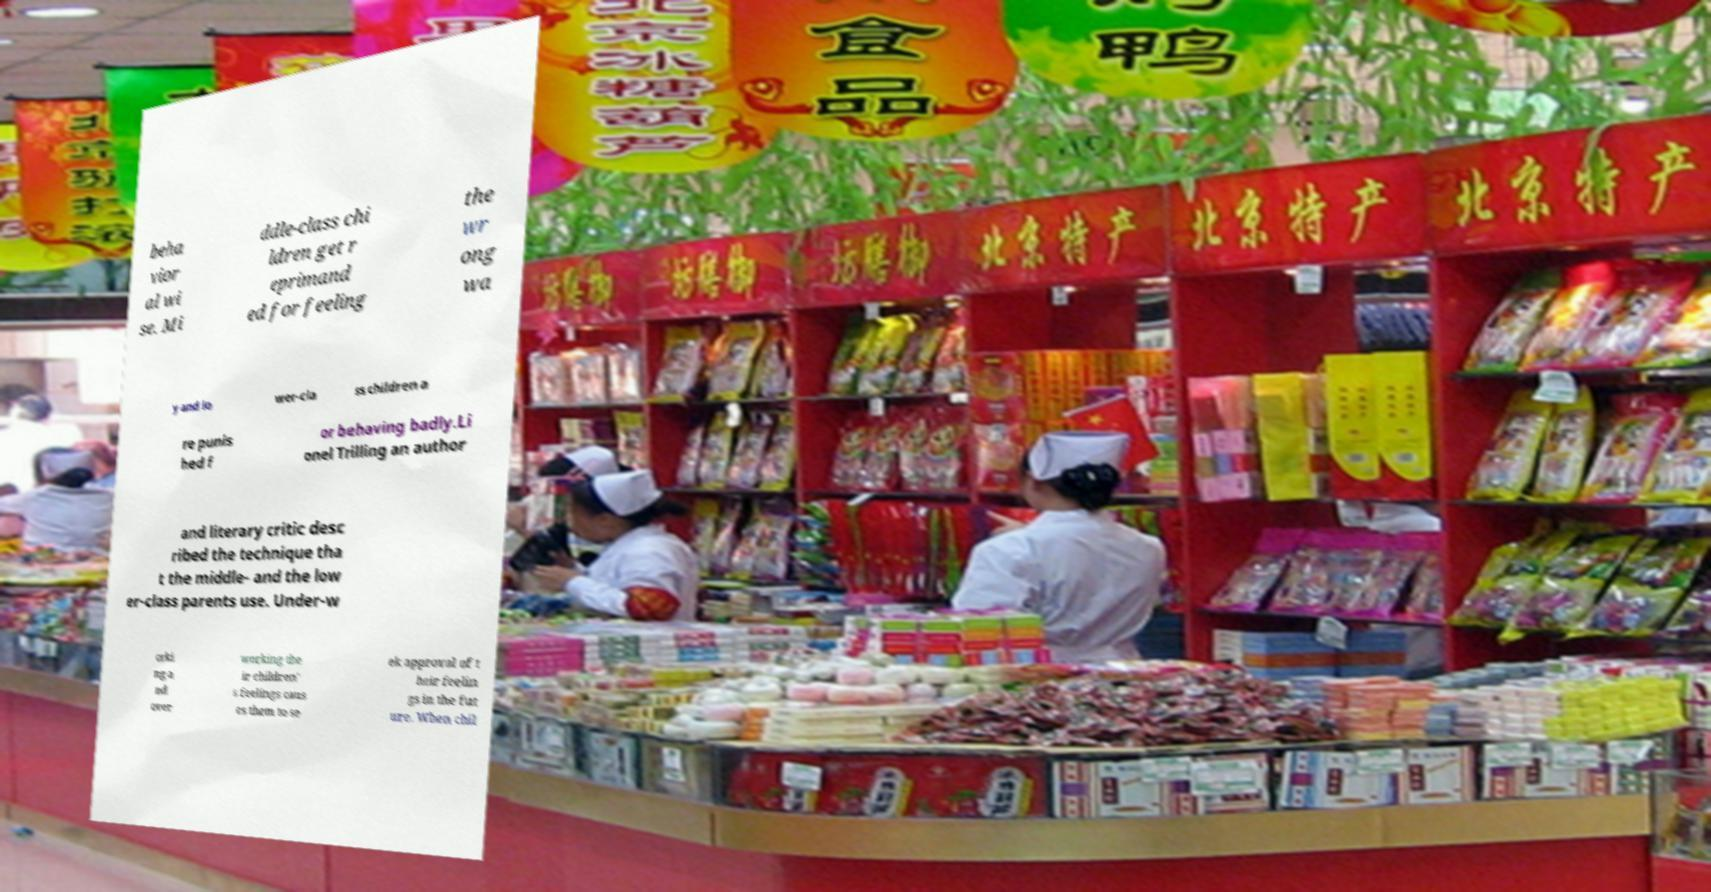Please identify and transcribe the text found in this image. beha vior al wi se. Mi ddle-class chi ldren get r eprimand ed for feeling the wr ong wa y and lo wer-cla ss children a re punis hed f or behaving badly.Li onel Trilling an author and literary critic desc ribed the technique tha t the middle- and the low er-class parents use. Under-w orki ng a nd over working the ir children' s feelings caus es them to se ek approval of t heir feelin gs in the fut ure. When chil 